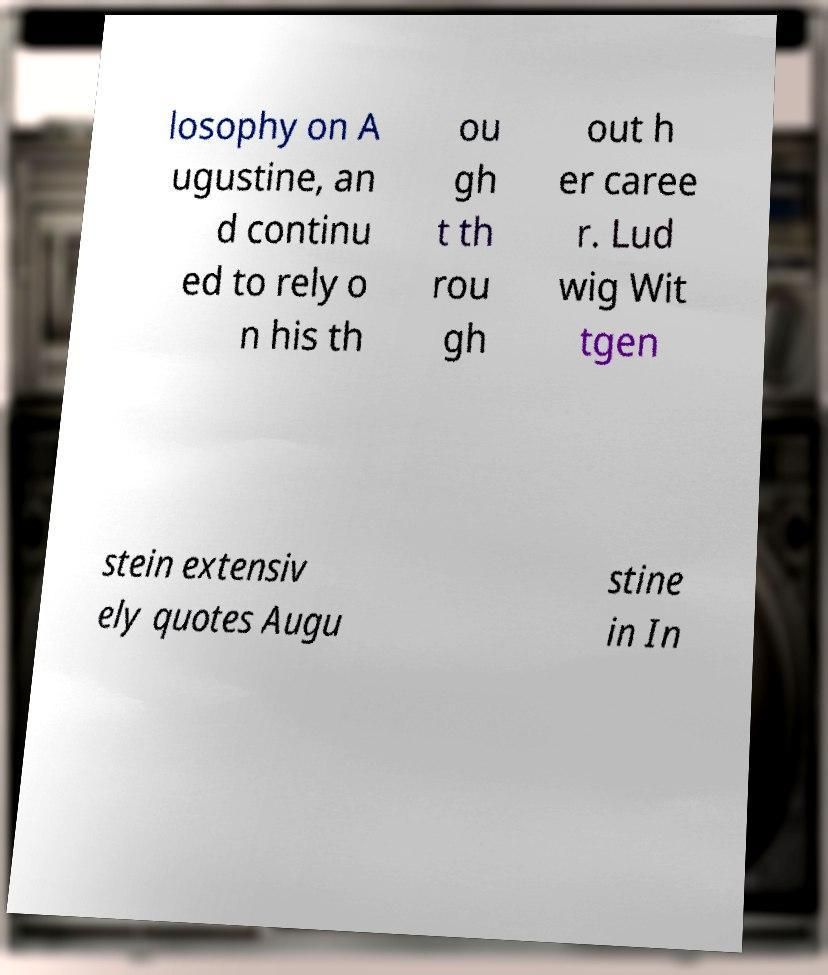I need the written content from this picture converted into text. Can you do that? losophy on A ugustine, an d continu ed to rely o n his th ou gh t th rou gh out h er caree r. Lud wig Wit tgen stein extensiv ely quotes Augu stine in In 